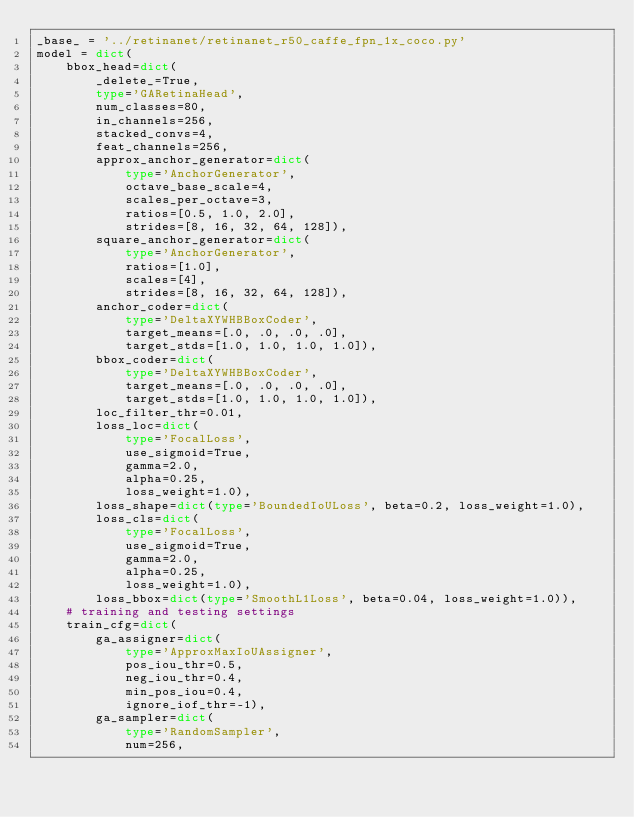<code> <loc_0><loc_0><loc_500><loc_500><_Python_>_base_ = '../retinanet/retinanet_r50_caffe_fpn_1x_coco.py'
model = dict(
    bbox_head=dict(
        _delete_=True,
        type='GARetinaHead',
        num_classes=80,
        in_channels=256,
        stacked_convs=4,
        feat_channels=256,
        approx_anchor_generator=dict(
            type='AnchorGenerator',
            octave_base_scale=4,
            scales_per_octave=3,
            ratios=[0.5, 1.0, 2.0],
            strides=[8, 16, 32, 64, 128]),
        square_anchor_generator=dict(
            type='AnchorGenerator',
            ratios=[1.0],
            scales=[4],
            strides=[8, 16, 32, 64, 128]),
        anchor_coder=dict(
            type='DeltaXYWHBBoxCoder',
            target_means=[.0, .0, .0, .0],
            target_stds=[1.0, 1.0, 1.0, 1.0]),
        bbox_coder=dict(
            type='DeltaXYWHBBoxCoder',
            target_means=[.0, .0, .0, .0],
            target_stds=[1.0, 1.0, 1.0, 1.0]),
        loc_filter_thr=0.01,
        loss_loc=dict(
            type='FocalLoss',
            use_sigmoid=True,
            gamma=2.0,
            alpha=0.25,
            loss_weight=1.0),
        loss_shape=dict(type='BoundedIoULoss', beta=0.2, loss_weight=1.0),
        loss_cls=dict(
            type='FocalLoss',
            use_sigmoid=True,
            gamma=2.0,
            alpha=0.25,
            loss_weight=1.0),
        loss_bbox=dict(type='SmoothL1Loss', beta=0.04, loss_weight=1.0)),
    # training and testing settings
    train_cfg=dict(
        ga_assigner=dict(
            type='ApproxMaxIoUAssigner',
            pos_iou_thr=0.5,
            neg_iou_thr=0.4,
            min_pos_iou=0.4,
            ignore_iof_thr=-1),
        ga_sampler=dict(
            type='RandomSampler',
            num=256,</code> 